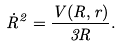<formula> <loc_0><loc_0><loc_500><loc_500>\dot { R } ^ { 2 } = \frac { V ( R , r ) } { 3 R } .</formula> 